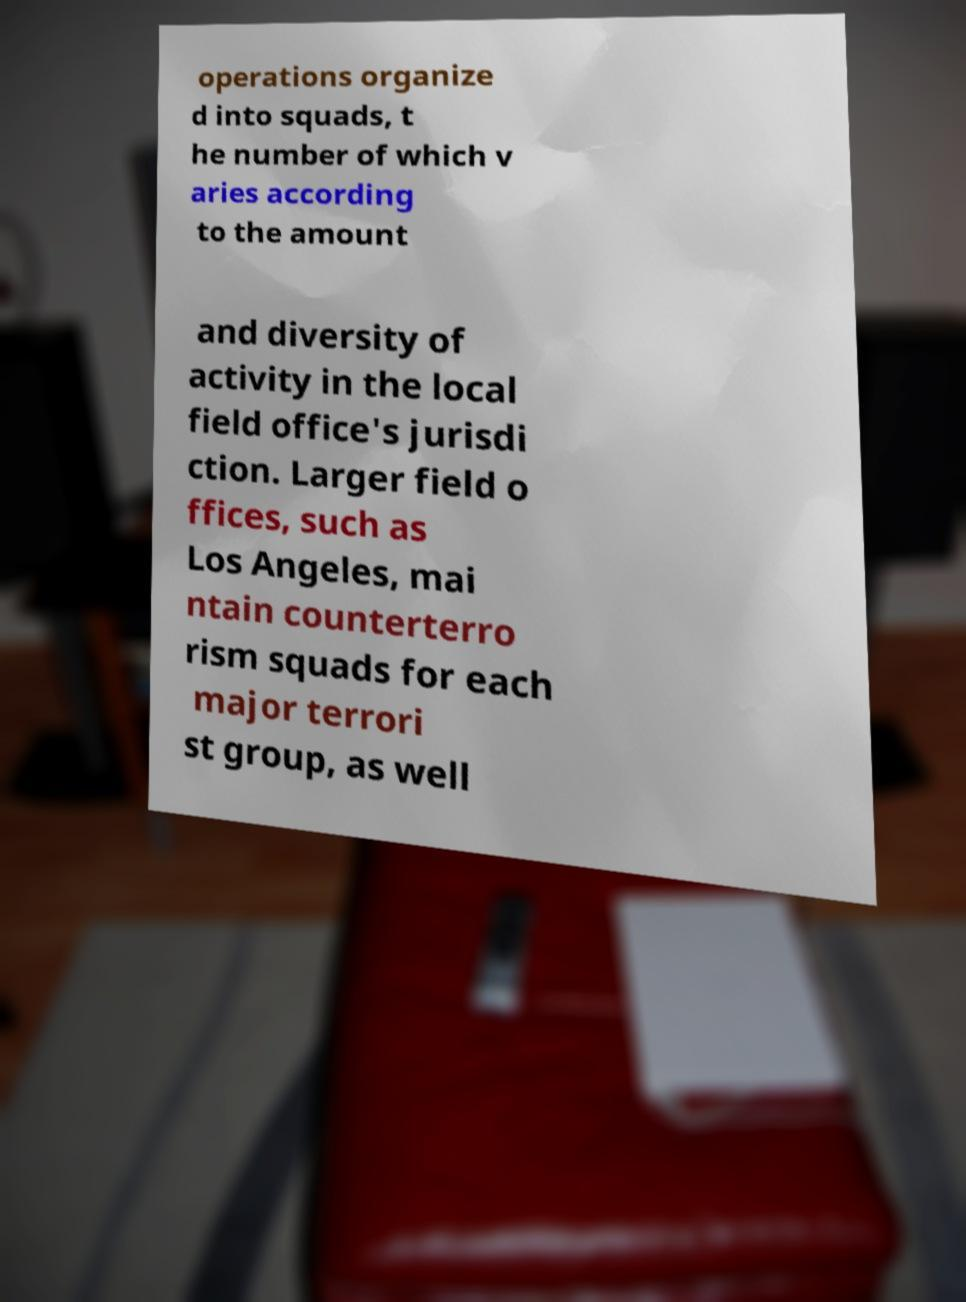Please read and relay the text visible in this image. What does it say? operations organize d into squads, t he number of which v aries according to the amount and diversity of activity in the local field office's jurisdi ction. Larger field o ffices, such as Los Angeles, mai ntain counterterro rism squads for each major terrori st group, as well 